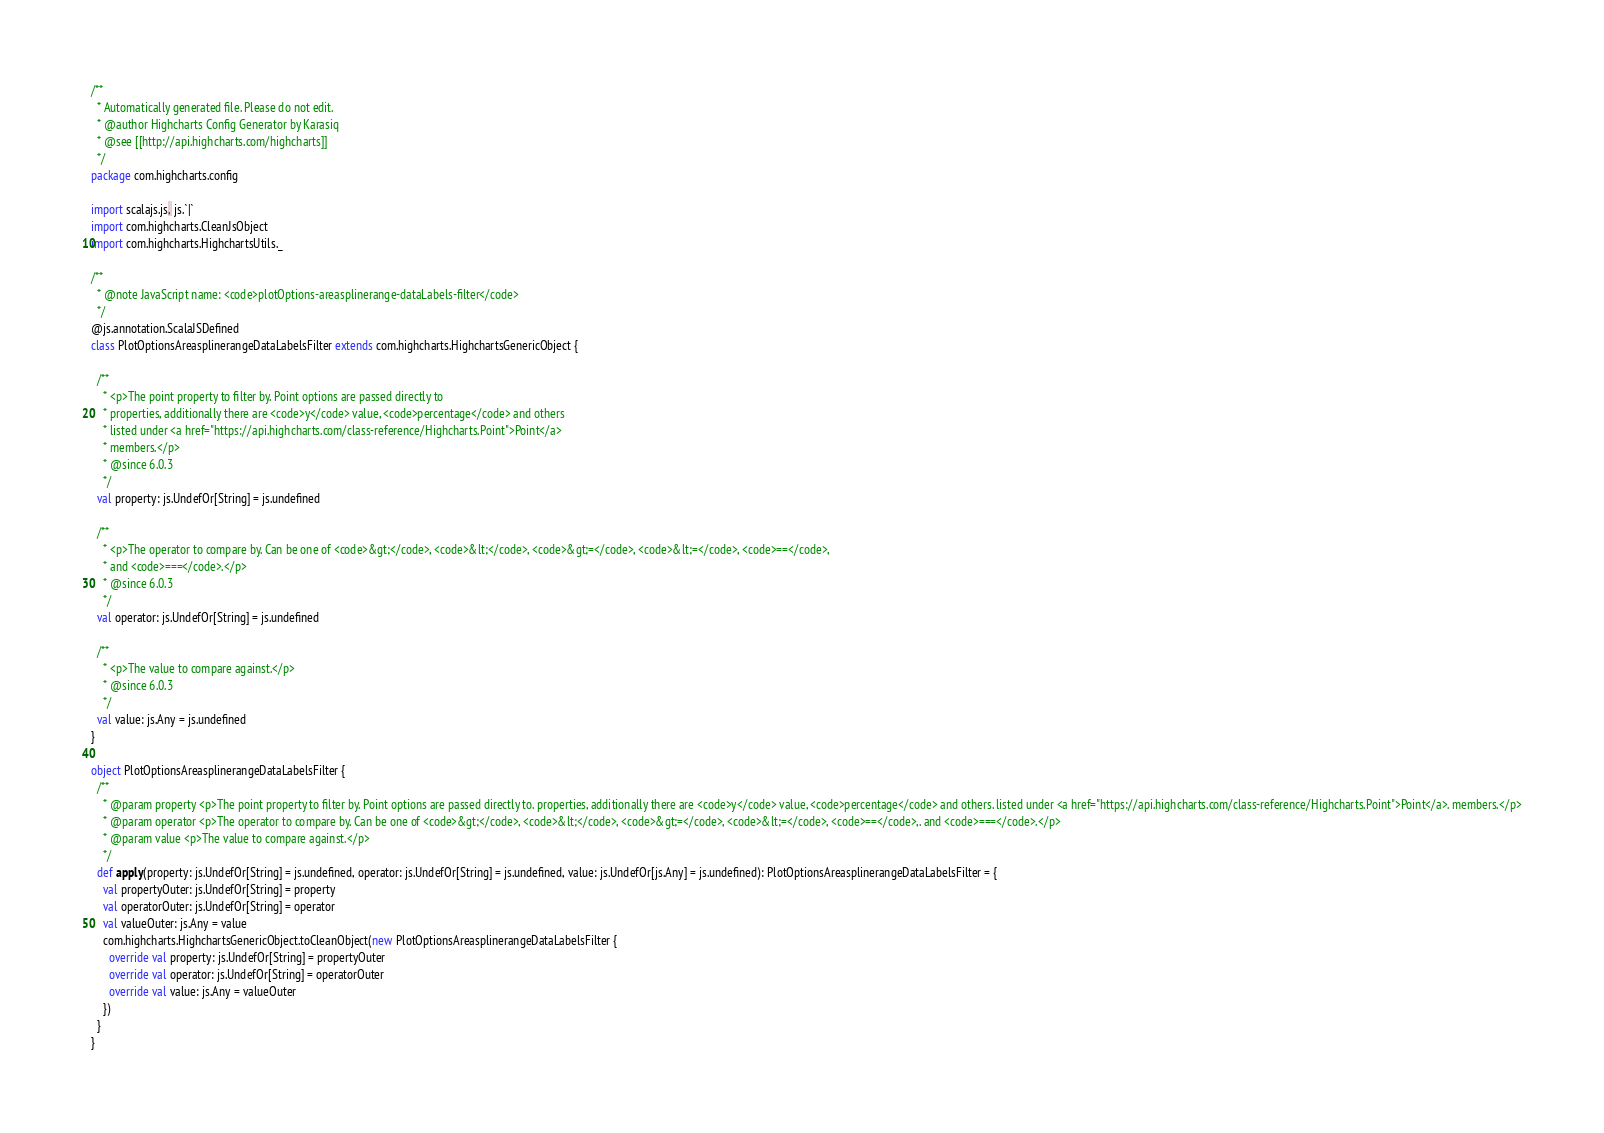Convert code to text. <code><loc_0><loc_0><loc_500><loc_500><_Scala_>/**
  * Automatically generated file. Please do not edit.
  * @author Highcharts Config Generator by Karasiq
  * @see [[http://api.highcharts.com/highcharts]]
  */
package com.highcharts.config

import scalajs.js, js.`|`
import com.highcharts.CleanJsObject
import com.highcharts.HighchartsUtils._

/**
  * @note JavaScript name: <code>plotOptions-areasplinerange-dataLabels-filter</code>
  */
@js.annotation.ScalaJSDefined
class PlotOptionsAreasplinerangeDataLabelsFilter extends com.highcharts.HighchartsGenericObject {

  /**
    * <p>The point property to filter by. Point options are passed directly to
    * properties, additionally there are <code>y</code> value, <code>percentage</code> and others
    * listed under <a href="https://api.highcharts.com/class-reference/Highcharts.Point">Point</a>
    * members.</p>
    * @since 6.0.3
    */
  val property: js.UndefOr[String] = js.undefined

  /**
    * <p>The operator to compare by. Can be one of <code>&gt;</code>, <code>&lt;</code>, <code>&gt;=</code>, <code>&lt;=</code>, <code>==</code>,
    * and <code>===</code>.</p>
    * @since 6.0.3
    */
  val operator: js.UndefOr[String] = js.undefined

  /**
    * <p>The value to compare against.</p>
    * @since 6.0.3
    */
  val value: js.Any = js.undefined
}

object PlotOptionsAreasplinerangeDataLabelsFilter {
  /**
    * @param property <p>The point property to filter by. Point options are passed directly to. properties, additionally there are <code>y</code> value, <code>percentage</code> and others. listed under <a href="https://api.highcharts.com/class-reference/Highcharts.Point">Point</a>. members.</p>
    * @param operator <p>The operator to compare by. Can be one of <code>&gt;</code>, <code>&lt;</code>, <code>&gt;=</code>, <code>&lt;=</code>, <code>==</code>,. and <code>===</code>.</p>
    * @param value <p>The value to compare against.</p>
    */
  def apply(property: js.UndefOr[String] = js.undefined, operator: js.UndefOr[String] = js.undefined, value: js.UndefOr[js.Any] = js.undefined): PlotOptionsAreasplinerangeDataLabelsFilter = {
    val propertyOuter: js.UndefOr[String] = property
    val operatorOuter: js.UndefOr[String] = operator
    val valueOuter: js.Any = value
    com.highcharts.HighchartsGenericObject.toCleanObject(new PlotOptionsAreasplinerangeDataLabelsFilter {
      override val property: js.UndefOr[String] = propertyOuter
      override val operator: js.UndefOr[String] = operatorOuter
      override val value: js.Any = valueOuter
    })
  }
}
</code> 